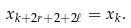<formula> <loc_0><loc_0><loc_500><loc_500>x _ { k + 2 r + 2 + 2 \ell } = x _ { k } .</formula> 